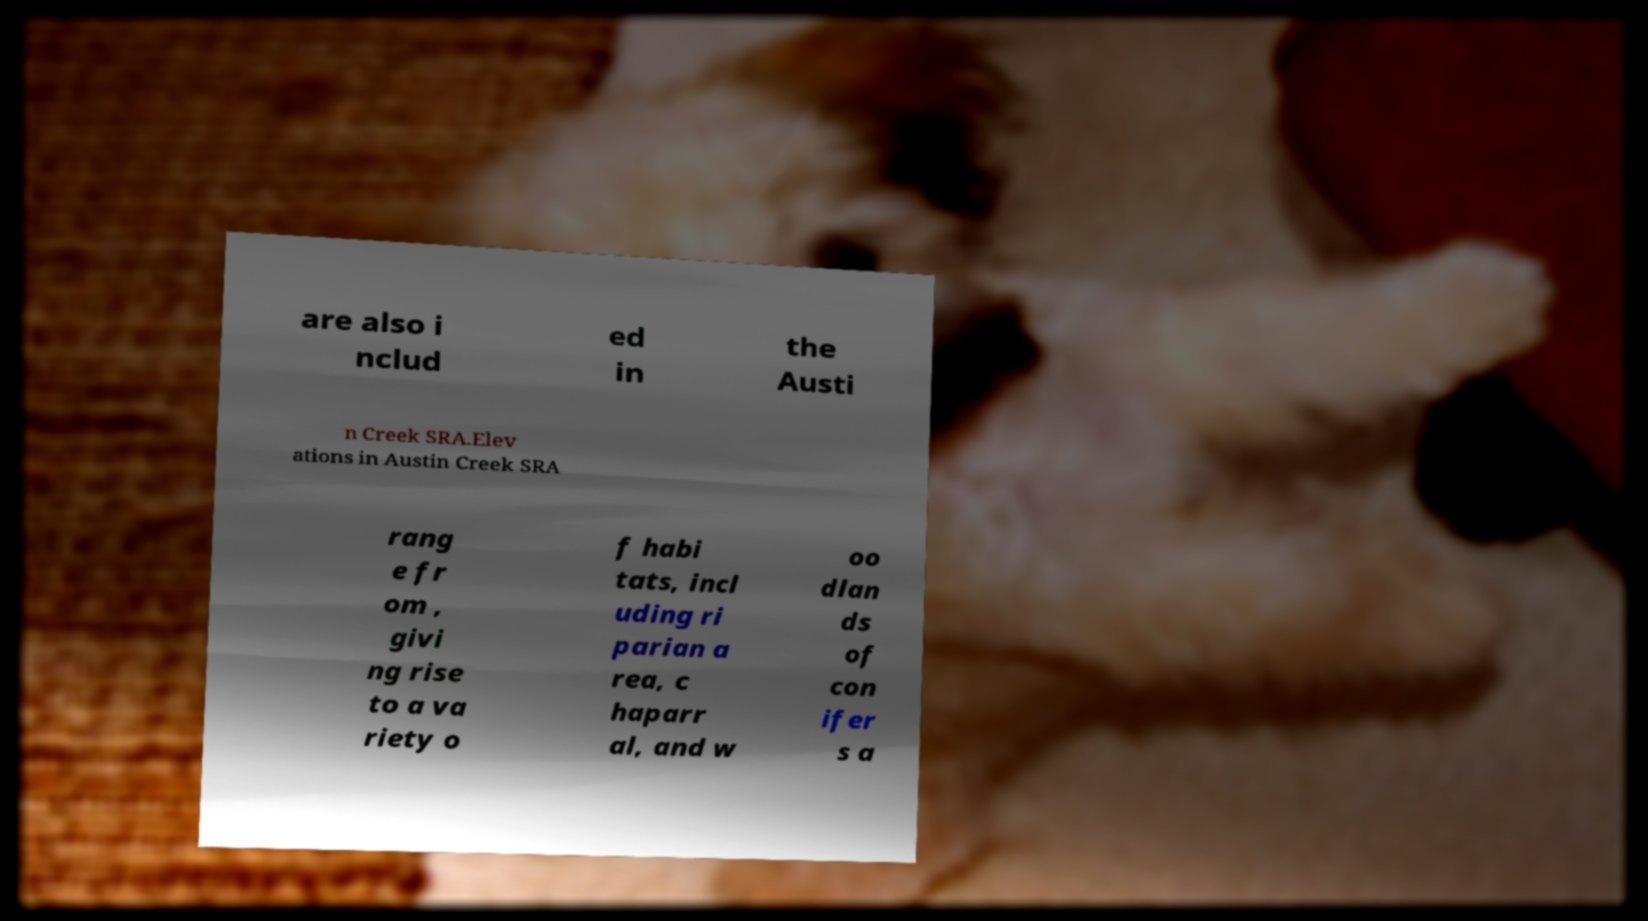What messages or text are displayed in this image? I need them in a readable, typed format. are also i nclud ed in the Austi n Creek SRA.Elev ations in Austin Creek SRA rang e fr om , givi ng rise to a va riety o f habi tats, incl uding ri parian a rea, c haparr al, and w oo dlan ds of con ifer s a 